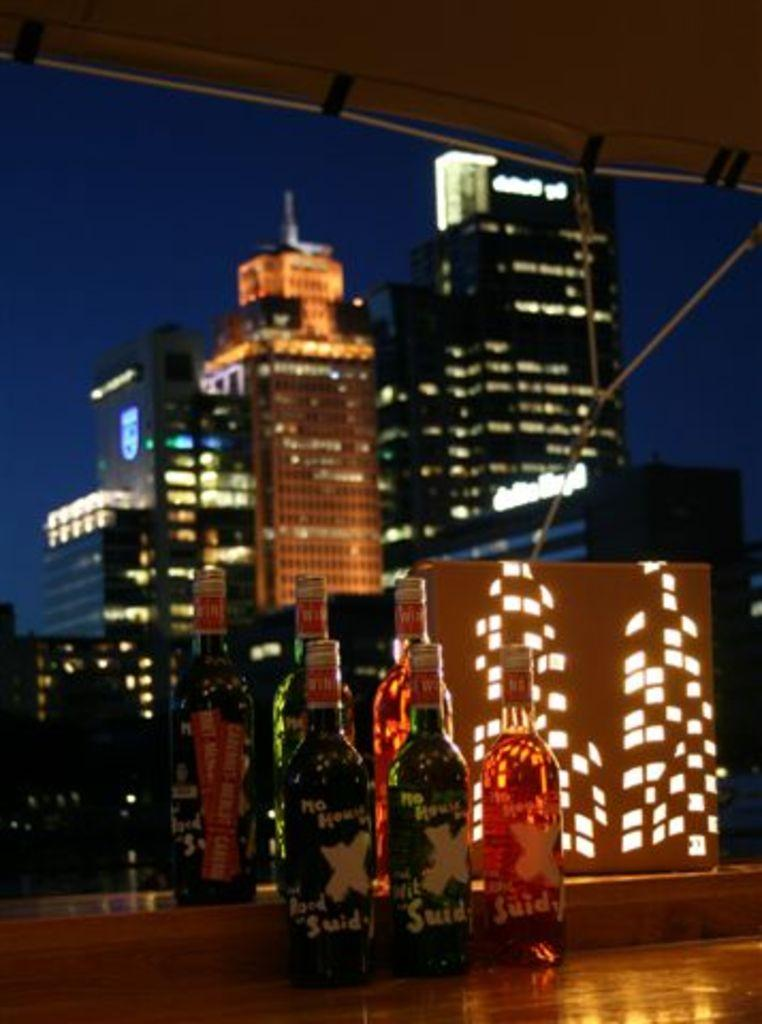<image>
Relay a brief, clear account of the picture shown. Bottles of No House Suid next to a window overlooking a city. 